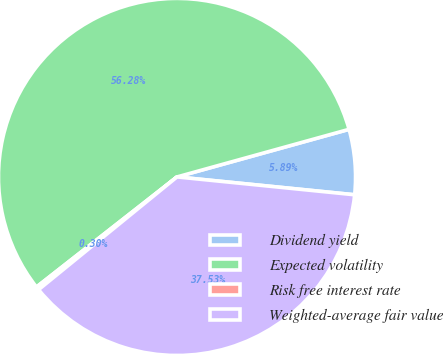Convert chart. <chart><loc_0><loc_0><loc_500><loc_500><pie_chart><fcel>Dividend yield<fcel>Expected volatility<fcel>Risk free interest rate<fcel>Weighted-average fair value<nl><fcel>5.89%<fcel>56.28%<fcel>0.3%<fcel>37.53%<nl></chart> 